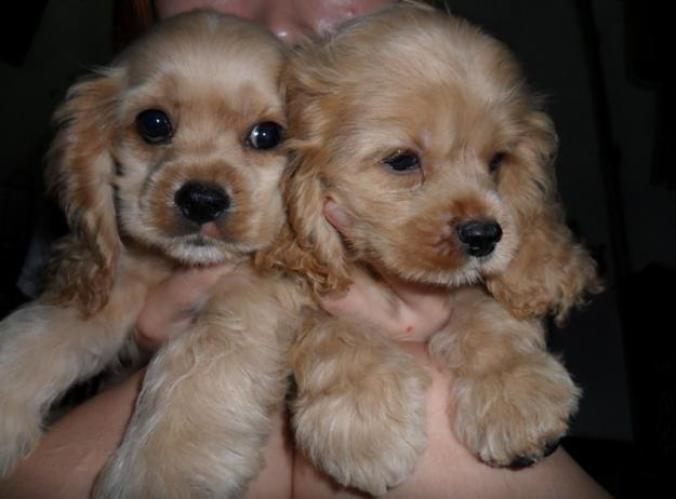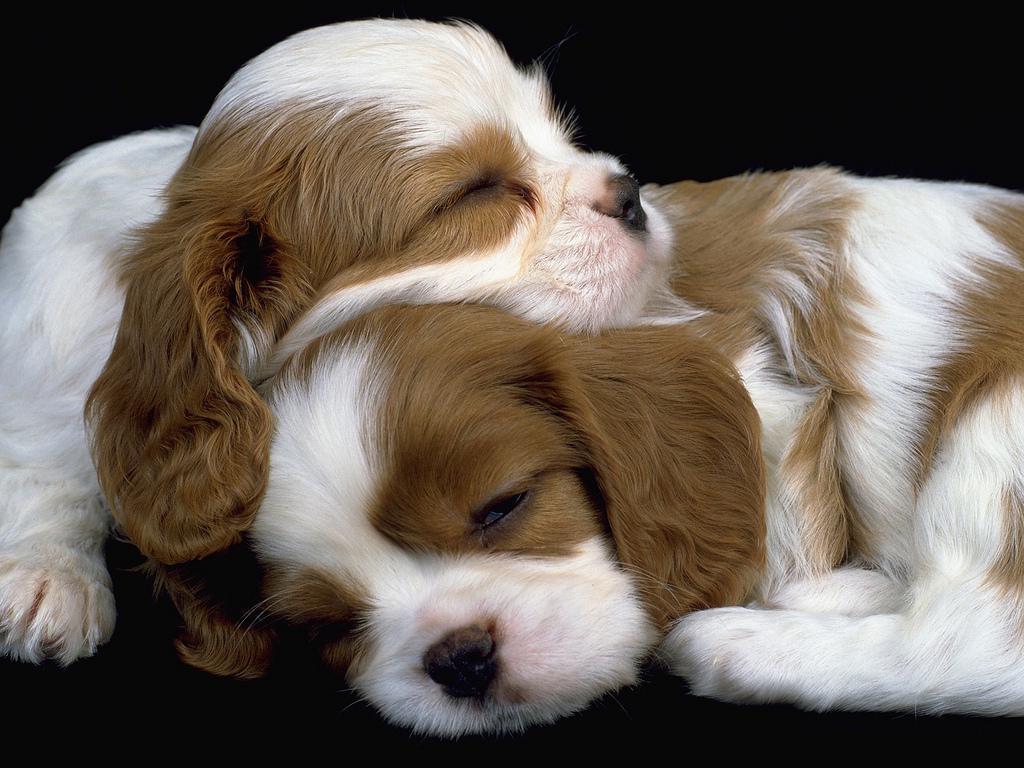The first image is the image on the left, the second image is the image on the right. Considering the images on both sides, is "One image includes at least one spaniel in a sleeping pose with shut eyes, and the other includes at least one 'ginger' spaniel with open eyes." valid? Answer yes or no. Yes. The first image is the image on the left, the second image is the image on the right. For the images shown, is this caption "A dog is lying on a leather sofa in both images." true? Answer yes or no. No. 